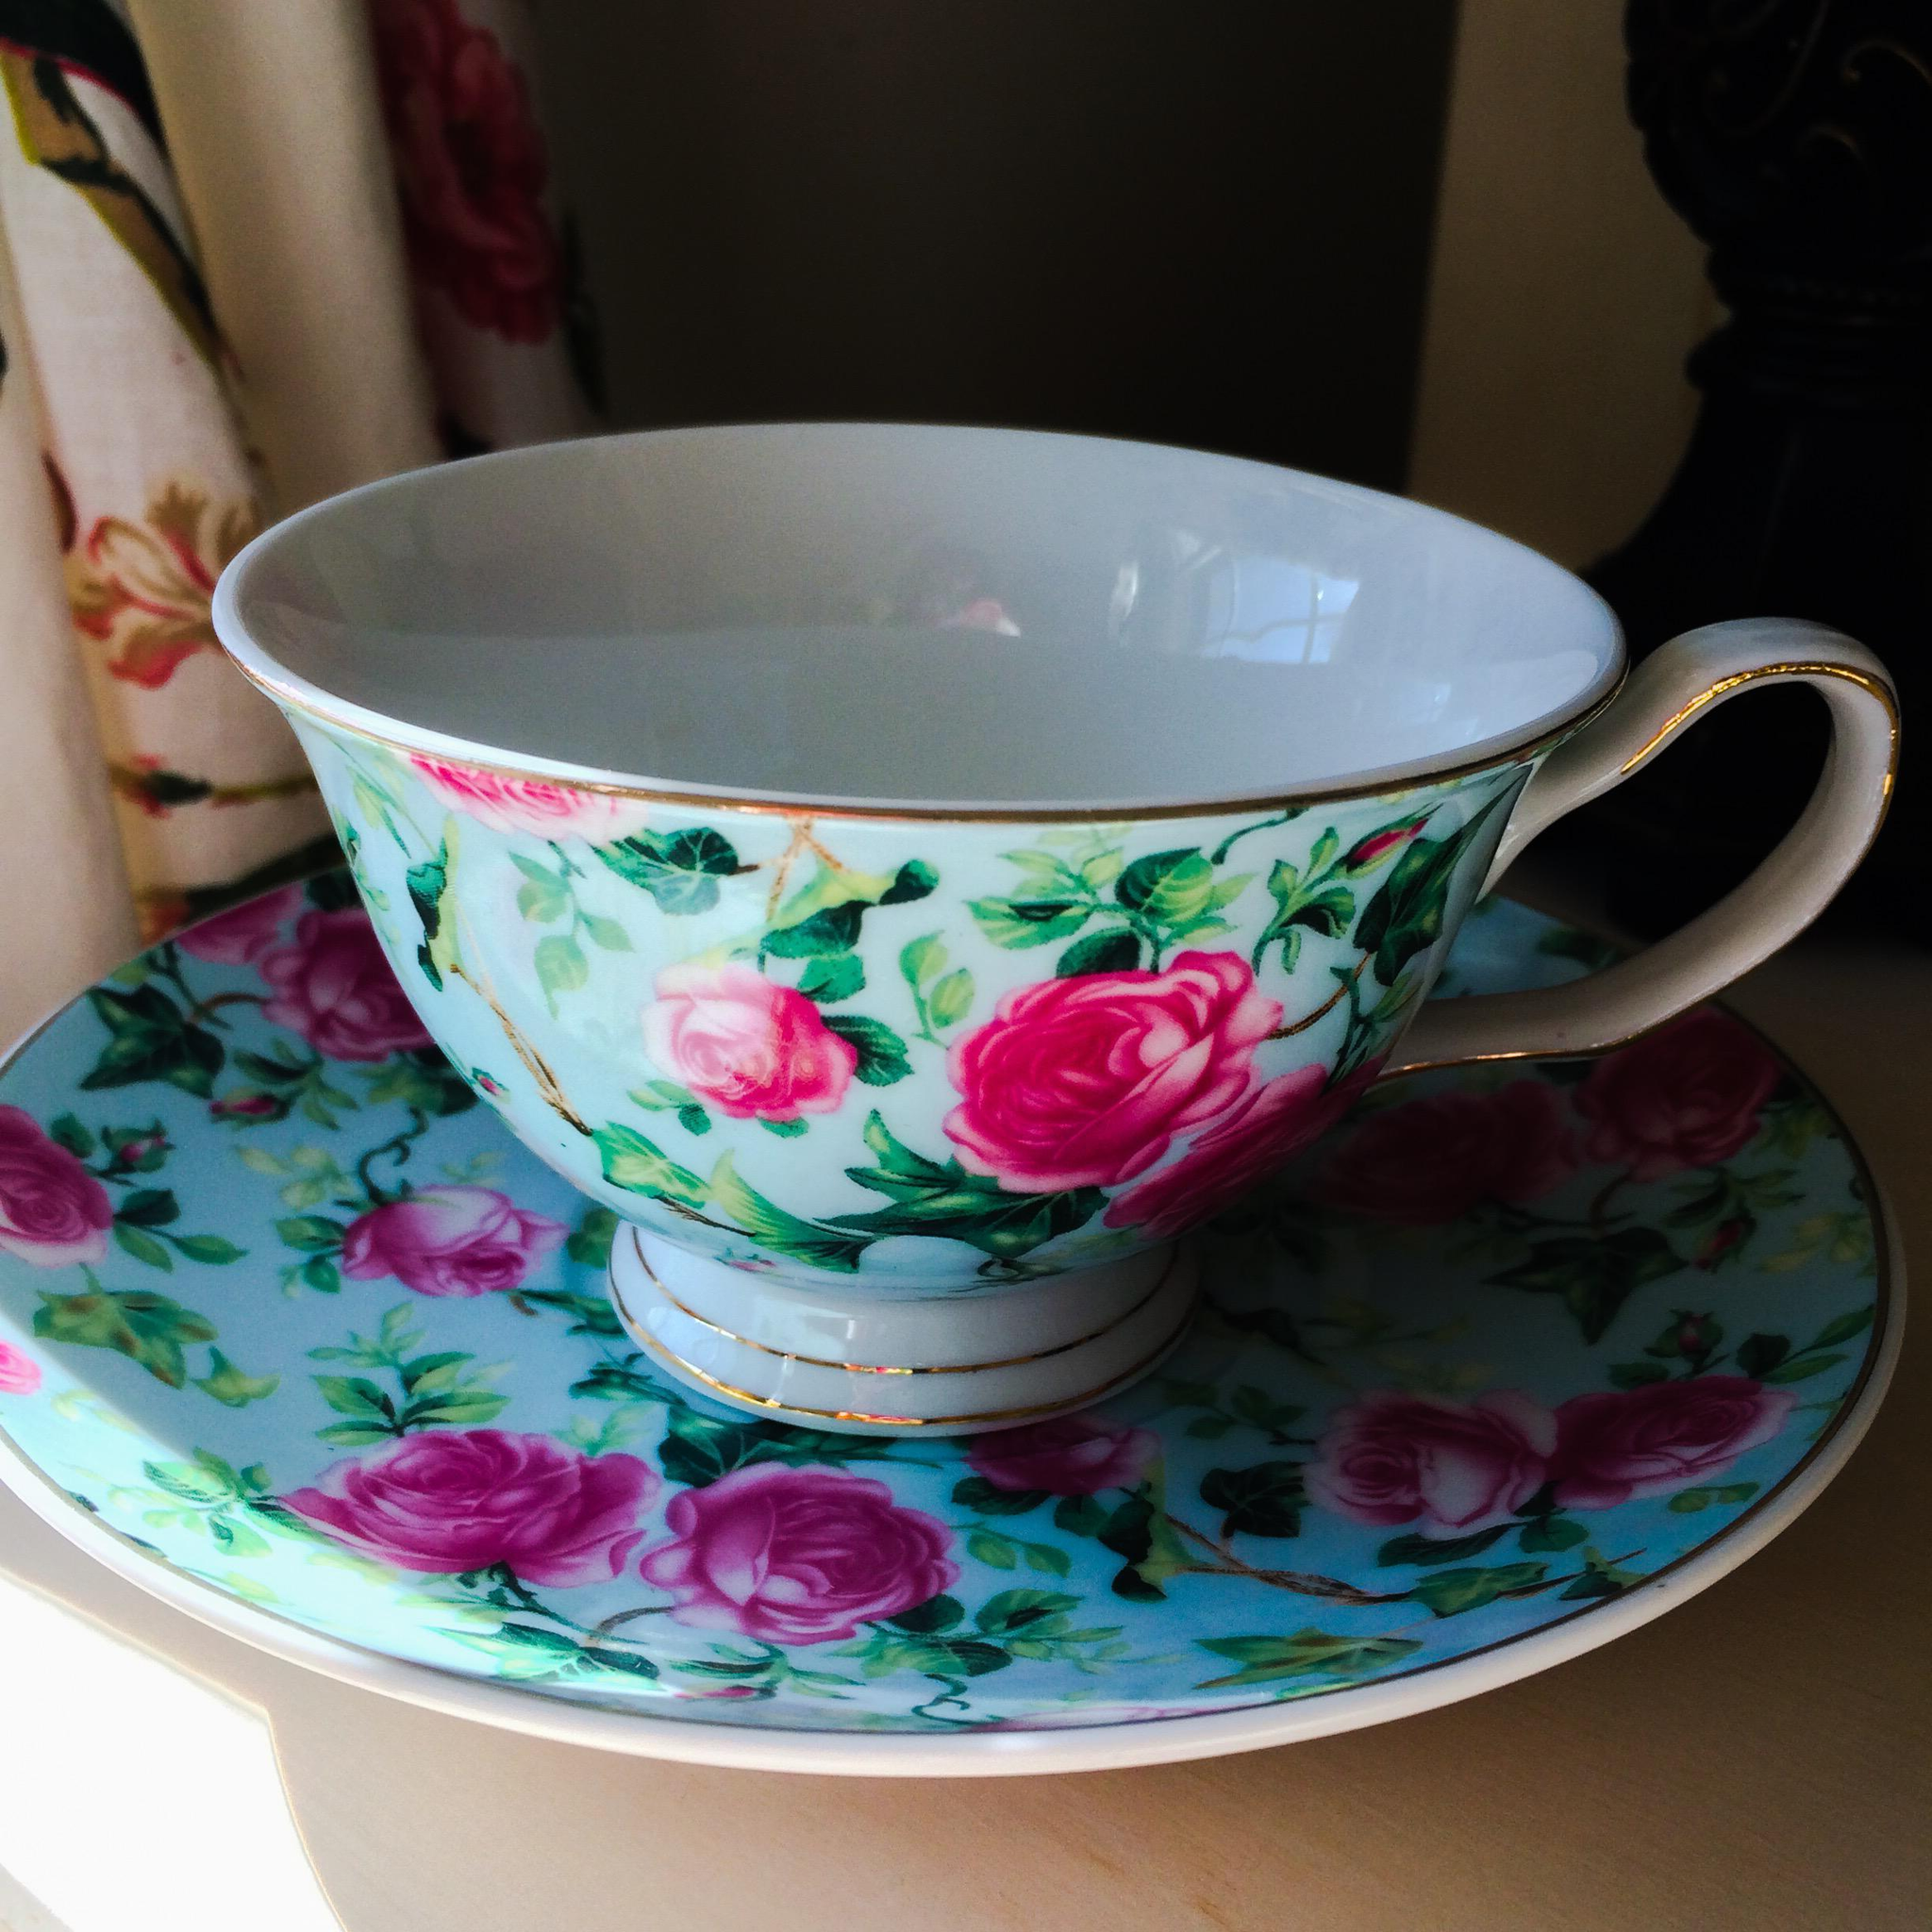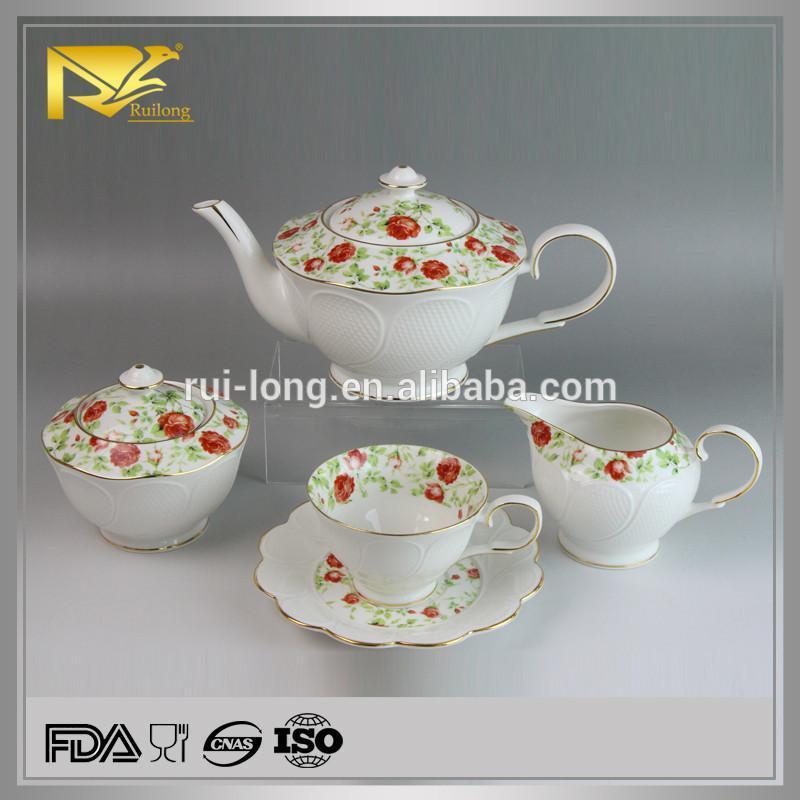The first image is the image on the left, the second image is the image on the right. Analyze the images presented: Is the assertion "One of the teacups is blue with pink flowers on it." valid? Answer yes or no. Yes. The first image is the image on the left, the second image is the image on the right. Assess this claim about the two images: "No more than one tea pot is visible.". Correct or not? Answer yes or no. Yes. 